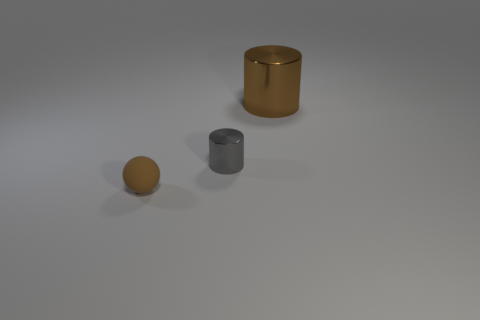Are there any other things that have the same material as the tiny sphere?
Give a very brief answer. No. The metallic thing that is to the left of the brown metal object has what shape?
Provide a succinct answer. Cylinder. Does the small gray object have the same material as the brown thing that is right of the matte ball?
Make the answer very short. Yes. How many other objects are there of the same shape as the large brown shiny object?
Give a very brief answer. 1. There is a big cylinder; is its color the same as the small thing that is behind the tiny brown matte object?
Provide a short and direct response. No. What is the shape of the brown thing left of the brown thing that is behind the rubber sphere?
Give a very brief answer. Sphere. What size is the cylinder that is the same color as the small matte thing?
Keep it short and to the point. Large. There is a brown object behind the small gray object; is it the same shape as the brown matte thing?
Provide a short and direct response. No. Are there more tiny metal objects behind the gray thing than rubber objects that are left of the small brown ball?
Keep it short and to the point. No. There is a brown thing behind the tiny rubber object; how many tiny things are in front of it?
Your response must be concise. 2. 